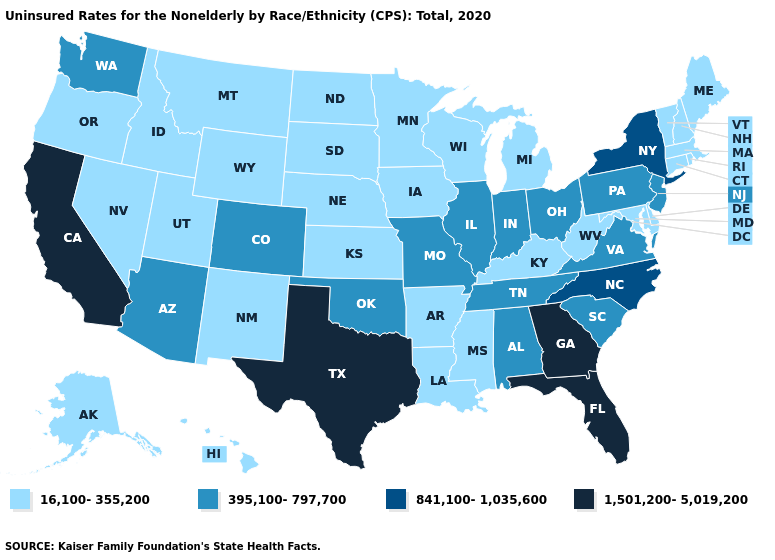What is the lowest value in the USA?
Give a very brief answer. 16,100-355,200. What is the lowest value in the South?
Write a very short answer. 16,100-355,200. What is the lowest value in the Northeast?
Concise answer only. 16,100-355,200. Does Nevada have the lowest value in the West?
Be succinct. Yes. What is the highest value in the USA?
Quick response, please. 1,501,200-5,019,200. Which states hav the highest value in the Northeast?
Be succinct. New York. Does the first symbol in the legend represent the smallest category?
Quick response, please. Yes. Among the states that border New Jersey , does Pennsylvania have the lowest value?
Concise answer only. No. Among the states that border New Hampshire , which have the highest value?
Keep it brief. Maine, Massachusetts, Vermont. Name the states that have a value in the range 841,100-1,035,600?
Keep it brief. New York, North Carolina. Does Louisiana have the highest value in the South?
Keep it brief. No. What is the lowest value in the USA?
Quick response, please. 16,100-355,200. Does Wisconsin have the same value as Utah?
Quick response, please. Yes. 